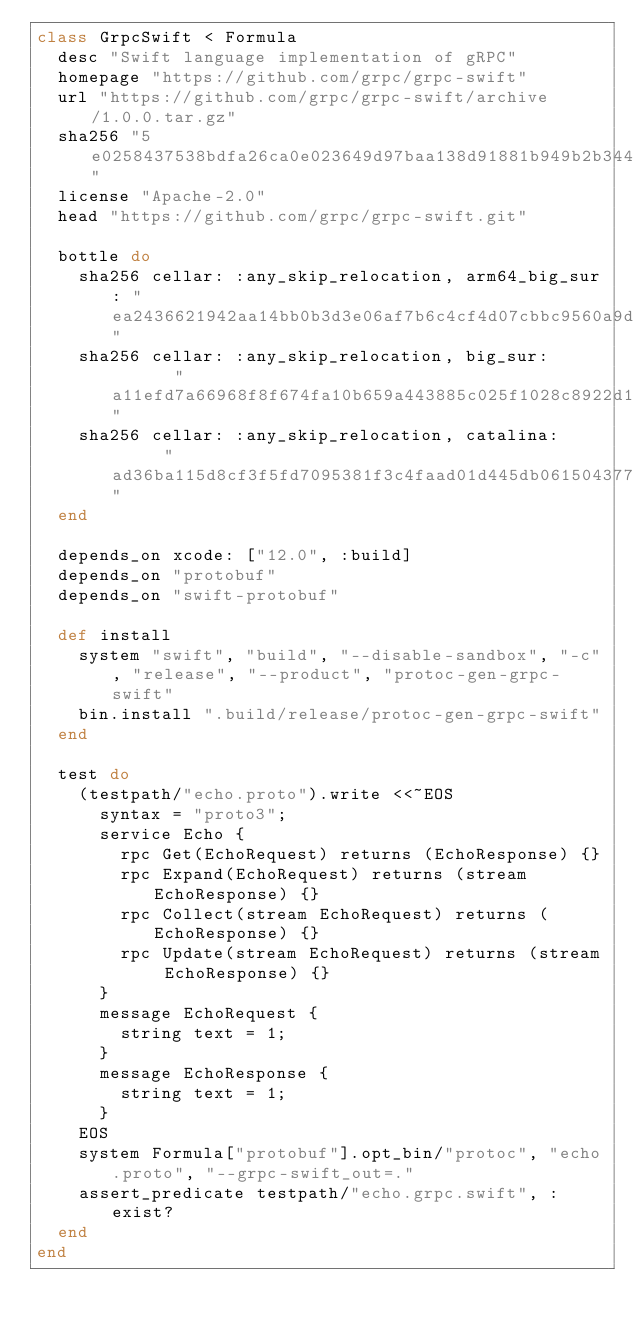Convert code to text. <code><loc_0><loc_0><loc_500><loc_500><_Ruby_>class GrpcSwift < Formula
  desc "Swift language implementation of gRPC"
  homepage "https://github.com/grpc/grpc-swift"
  url "https://github.com/grpc/grpc-swift/archive/1.0.0.tar.gz"
  sha256 "5e0258437538bdfa26ca0e023649d97baa138d91881b949b2b344ef84cc2082a"
  license "Apache-2.0"
  head "https://github.com/grpc/grpc-swift.git"

  bottle do
    sha256 cellar: :any_skip_relocation, arm64_big_sur: "ea2436621942aa14bb0b3d3e06af7b6c4cf4d07cbbc9560a9d853a6e7436abda"
    sha256 cellar: :any_skip_relocation, big_sur:       "a11efd7a66968f8f674fa10b659a443885c025f1028c8922d1f39240bb33a38c"
    sha256 cellar: :any_skip_relocation, catalina:      "ad36ba115d8cf3f5fd7095381f3c4faad01d445db061504377b7da23dfececcc"
  end

  depends_on xcode: ["12.0", :build]
  depends_on "protobuf"
  depends_on "swift-protobuf"

  def install
    system "swift", "build", "--disable-sandbox", "-c", "release", "--product", "protoc-gen-grpc-swift"
    bin.install ".build/release/protoc-gen-grpc-swift"
  end

  test do
    (testpath/"echo.proto").write <<~EOS
      syntax = "proto3";
      service Echo {
        rpc Get(EchoRequest) returns (EchoResponse) {}
        rpc Expand(EchoRequest) returns (stream EchoResponse) {}
        rpc Collect(stream EchoRequest) returns (EchoResponse) {}
        rpc Update(stream EchoRequest) returns (stream EchoResponse) {}
      }
      message EchoRequest {
        string text = 1;
      }
      message EchoResponse {
        string text = 1;
      }
    EOS
    system Formula["protobuf"].opt_bin/"protoc", "echo.proto", "--grpc-swift_out=."
    assert_predicate testpath/"echo.grpc.swift", :exist?
  end
end
</code> 